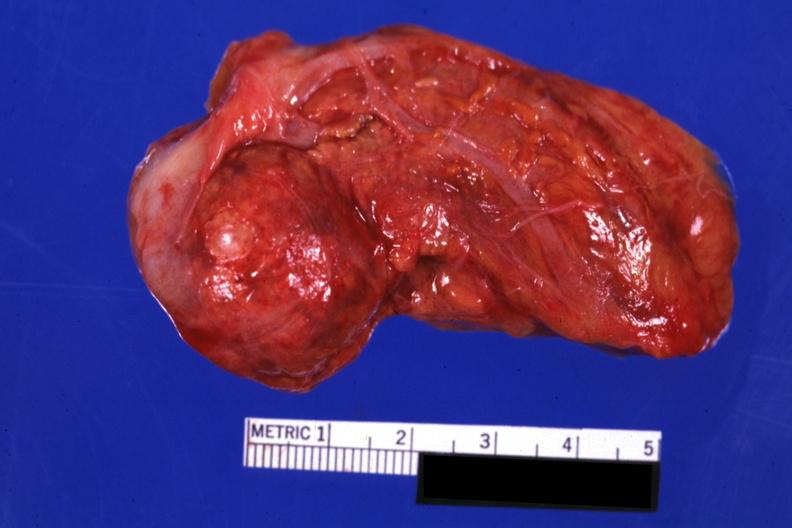s cortical nodule present?
Answer the question using a single word or phrase. Yes 